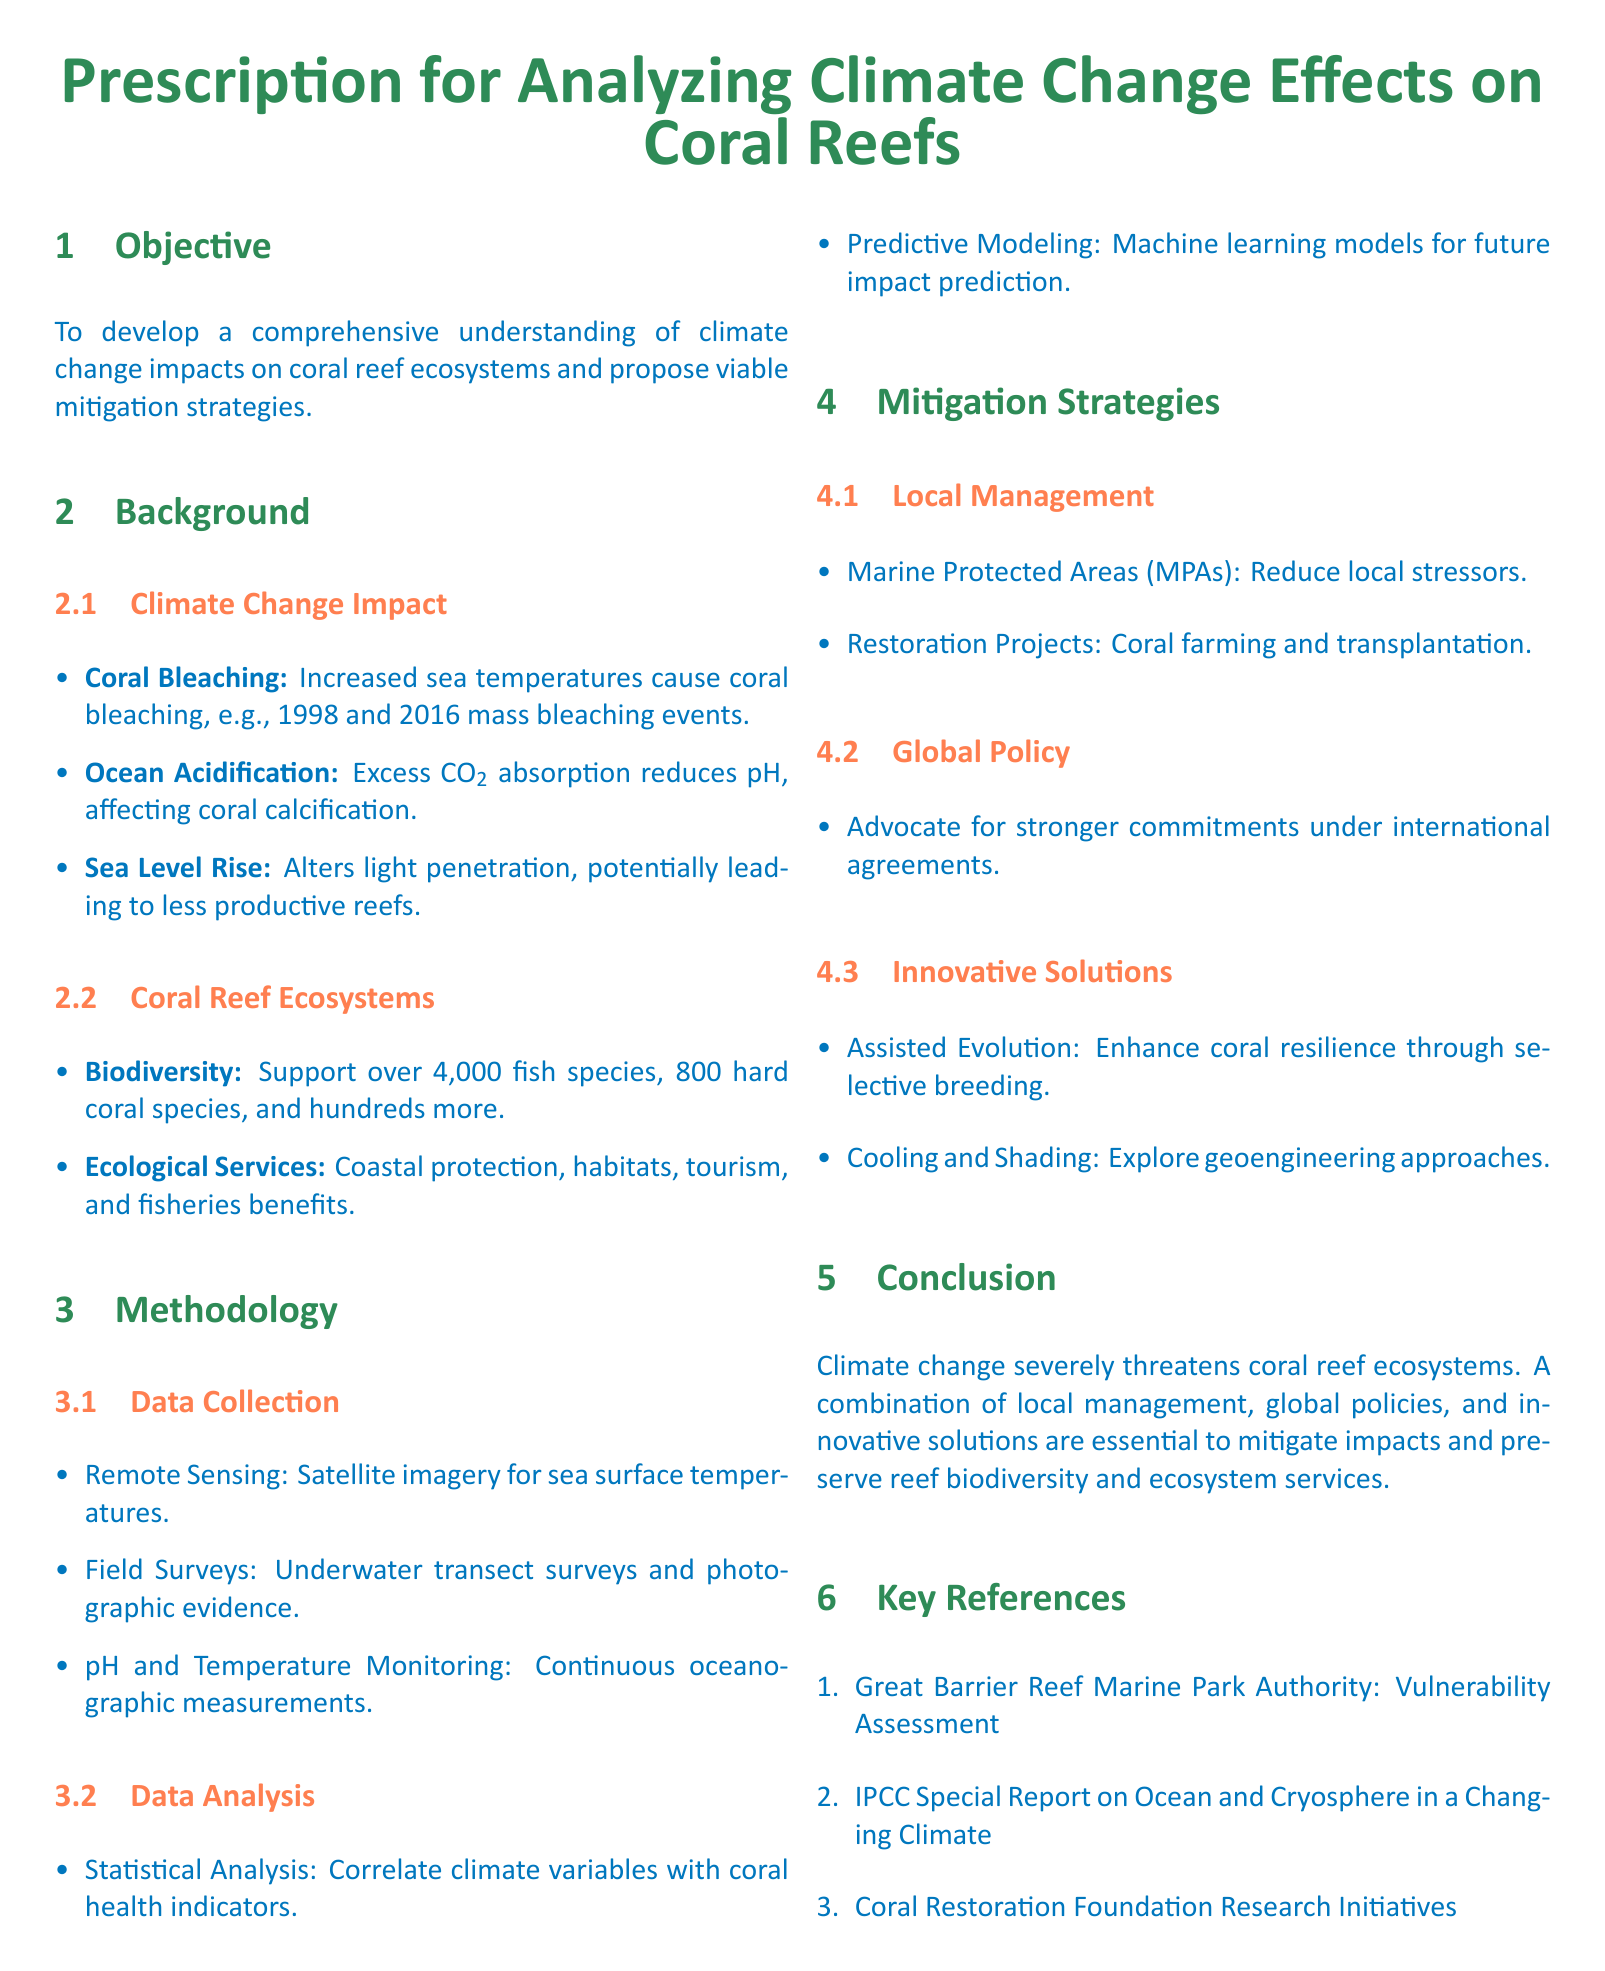What is the primary objective of the prescription? The primary objective is outlined as a comprehensive understanding of climate change impacts on coral reef ecosystems and proposing viable mitigation strategies.
Answer: To develop a comprehensive understanding of climate change impacts on coral reef ecosystems and propose viable mitigation strategies What are the two major impacts of climate change mentioned in the document? The document lists two significant impacts of climate change on coral reef ecosystems: coral bleaching and ocean acidification.
Answer: Coral Bleaching, Ocean Acidification How many fish species do coral reef ecosystems support? The document states that coral reef ecosystems support over 4,000 fish species.
Answer: Over 4,000 fish species What type of analysis is used for correlating climate variables with coral health indicators? The document mentions that statistical analysis is used for correlating climate variables with coral health indicators.
Answer: Statistical Analysis What is one proposed local management strategy mentioned? The document suggests Marine Protected Areas (MPAs) as a local management strategy to reduce stressors on coral reefs.
Answer: Marine Protected Areas (MPAs) What innovative solution is proposed to enhance coral resilience? The document proposes assisted evolution as an innovative solution to enhance coral resilience through selective breeding.
Answer: Assisted Evolution How many key references are listed in the document? The document lists three key references related to the prescription.
Answer: Three What does the conclusion emphasize as essential for preserving reef biodiversity? The conclusion emphasizes that a combination of local management, global policies, and innovative solutions is essential for preserving reef biodiversity.
Answer: A combination of local management, global policies, and innovative solutions 